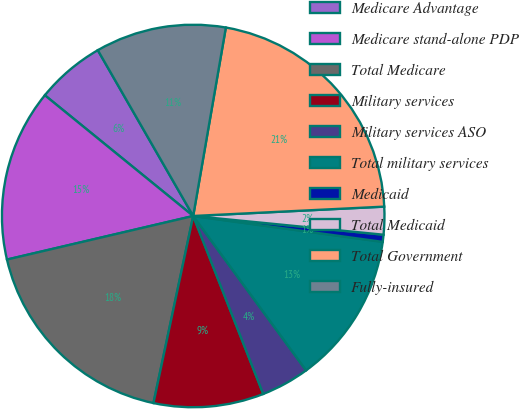Convert chart to OTSL. <chart><loc_0><loc_0><loc_500><loc_500><pie_chart><fcel>Medicare Advantage<fcel>Medicare stand-alone PDP<fcel>Total Medicare<fcel>Military services<fcel>Military services ASO<fcel>Total military services<fcel>Medicaid<fcel>Total Medicaid<fcel>Total Government<fcel>Fully-insured<nl><fcel>5.82%<fcel>14.53%<fcel>18.01%<fcel>9.3%<fcel>4.08%<fcel>12.79%<fcel>0.6%<fcel>2.34%<fcel>21.49%<fcel>11.04%<nl></chart> 